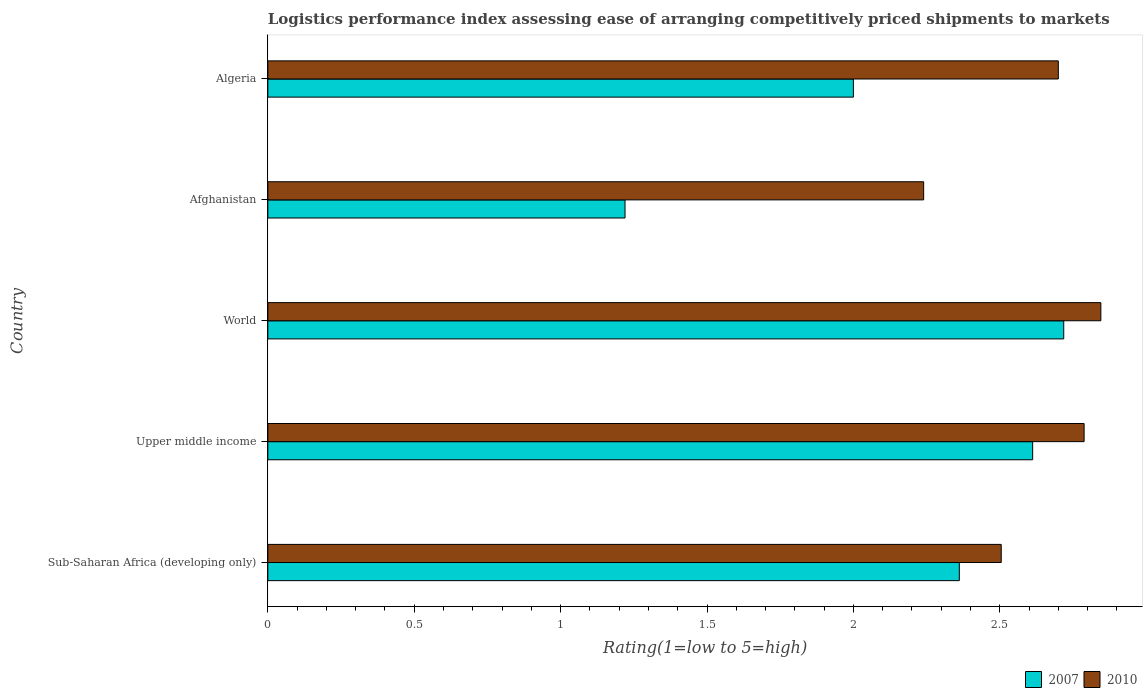How many different coloured bars are there?
Offer a very short reply. 2. Are the number of bars per tick equal to the number of legend labels?
Your response must be concise. Yes. How many bars are there on the 2nd tick from the top?
Your response must be concise. 2. How many bars are there on the 4th tick from the bottom?
Your answer should be compact. 2. What is the label of the 5th group of bars from the top?
Your response must be concise. Sub-Saharan Africa (developing only). Across all countries, what is the maximum Logistic performance index in 2007?
Your answer should be compact. 2.72. Across all countries, what is the minimum Logistic performance index in 2007?
Your answer should be very brief. 1.22. In which country was the Logistic performance index in 2007 maximum?
Your response must be concise. World. In which country was the Logistic performance index in 2007 minimum?
Make the answer very short. Afghanistan. What is the total Logistic performance index in 2010 in the graph?
Your response must be concise. 13.08. What is the difference between the Logistic performance index in 2007 in Sub-Saharan Africa (developing only) and that in Upper middle income?
Your answer should be compact. -0.25. What is the difference between the Logistic performance index in 2010 in Algeria and the Logistic performance index in 2007 in Afghanistan?
Make the answer very short. 1.48. What is the average Logistic performance index in 2010 per country?
Make the answer very short. 2.62. What is the difference between the Logistic performance index in 2010 and Logistic performance index in 2007 in World?
Your response must be concise. 0.13. In how many countries, is the Logistic performance index in 2007 greater than 0.4 ?
Give a very brief answer. 5. What is the ratio of the Logistic performance index in 2007 in Sub-Saharan Africa (developing only) to that in World?
Provide a succinct answer. 0.87. Is the Logistic performance index in 2010 in Upper middle income less than that in World?
Give a very brief answer. Yes. What is the difference between the highest and the second highest Logistic performance index in 2010?
Make the answer very short. 0.06. What is the difference between the highest and the lowest Logistic performance index in 2007?
Give a very brief answer. 1.5. In how many countries, is the Logistic performance index in 2007 greater than the average Logistic performance index in 2007 taken over all countries?
Offer a very short reply. 3. What does the 2nd bar from the bottom in World represents?
Keep it short and to the point. 2010. Are all the bars in the graph horizontal?
Give a very brief answer. Yes. Are the values on the major ticks of X-axis written in scientific E-notation?
Offer a very short reply. No. Does the graph contain any zero values?
Make the answer very short. No. Where does the legend appear in the graph?
Provide a short and direct response. Bottom right. What is the title of the graph?
Keep it short and to the point. Logistics performance index assessing ease of arranging competitively priced shipments to markets. What is the label or title of the X-axis?
Keep it short and to the point. Rating(1=low to 5=high). What is the Rating(1=low to 5=high) in 2007 in Sub-Saharan Africa (developing only)?
Give a very brief answer. 2.36. What is the Rating(1=low to 5=high) in 2010 in Sub-Saharan Africa (developing only)?
Your answer should be very brief. 2.5. What is the Rating(1=low to 5=high) of 2007 in Upper middle income?
Provide a succinct answer. 2.61. What is the Rating(1=low to 5=high) of 2010 in Upper middle income?
Provide a succinct answer. 2.79. What is the Rating(1=low to 5=high) of 2007 in World?
Offer a very short reply. 2.72. What is the Rating(1=low to 5=high) of 2010 in World?
Give a very brief answer. 2.85. What is the Rating(1=low to 5=high) in 2007 in Afghanistan?
Ensure brevity in your answer.  1.22. What is the Rating(1=low to 5=high) of 2010 in Afghanistan?
Your response must be concise. 2.24. What is the Rating(1=low to 5=high) of 2007 in Algeria?
Provide a short and direct response. 2. What is the Rating(1=low to 5=high) in 2010 in Algeria?
Offer a terse response. 2.7. Across all countries, what is the maximum Rating(1=low to 5=high) of 2007?
Your response must be concise. 2.72. Across all countries, what is the maximum Rating(1=low to 5=high) of 2010?
Keep it short and to the point. 2.85. Across all countries, what is the minimum Rating(1=low to 5=high) of 2007?
Offer a very short reply. 1.22. Across all countries, what is the minimum Rating(1=low to 5=high) in 2010?
Your answer should be very brief. 2.24. What is the total Rating(1=low to 5=high) of 2007 in the graph?
Your answer should be compact. 10.91. What is the total Rating(1=low to 5=high) of 2010 in the graph?
Offer a very short reply. 13.08. What is the difference between the Rating(1=low to 5=high) of 2007 in Sub-Saharan Africa (developing only) and that in Upper middle income?
Offer a very short reply. -0.25. What is the difference between the Rating(1=low to 5=high) of 2010 in Sub-Saharan Africa (developing only) and that in Upper middle income?
Provide a short and direct response. -0.28. What is the difference between the Rating(1=low to 5=high) of 2007 in Sub-Saharan Africa (developing only) and that in World?
Your answer should be very brief. -0.36. What is the difference between the Rating(1=low to 5=high) of 2010 in Sub-Saharan Africa (developing only) and that in World?
Ensure brevity in your answer.  -0.34. What is the difference between the Rating(1=low to 5=high) of 2007 in Sub-Saharan Africa (developing only) and that in Afghanistan?
Provide a short and direct response. 1.14. What is the difference between the Rating(1=low to 5=high) of 2010 in Sub-Saharan Africa (developing only) and that in Afghanistan?
Your answer should be compact. 0.27. What is the difference between the Rating(1=low to 5=high) in 2007 in Sub-Saharan Africa (developing only) and that in Algeria?
Make the answer very short. 0.36. What is the difference between the Rating(1=low to 5=high) of 2010 in Sub-Saharan Africa (developing only) and that in Algeria?
Keep it short and to the point. -0.2. What is the difference between the Rating(1=low to 5=high) of 2007 in Upper middle income and that in World?
Your answer should be compact. -0.11. What is the difference between the Rating(1=low to 5=high) in 2010 in Upper middle income and that in World?
Keep it short and to the point. -0.06. What is the difference between the Rating(1=low to 5=high) in 2007 in Upper middle income and that in Afghanistan?
Provide a succinct answer. 1.39. What is the difference between the Rating(1=low to 5=high) of 2010 in Upper middle income and that in Afghanistan?
Offer a terse response. 0.55. What is the difference between the Rating(1=low to 5=high) of 2007 in Upper middle income and that in Algeria?
Make the answer very short. 0.61. What is the difference between the Rating(1=low to 5=high) in 2010 in Upper middle income and that in Algeria?
Your response must be concise. 0.09. What is the difference between the Rating(1=low to 5=high) of 2007 in World and that in Afghanistan?
Ensure brevity in your answer.  1.5. What is the difference between the Rating(1=low to 5=high) of 2010 in World and that in Afghanistan?
Your response must be concise. 0.61. What is the difference between the Rating(1=low to 5=high) of 2007 in World and that in Algeria?
Give a very brief answer. 0.72. What is the difference between the Rating(1=low to 5=high) in 2010 in World and that in Algeria?
Ensure brevity in your answer.  0.15. What is the difference between the Rating(1=low to 5=high) in 2007 in Afghanistan and that in Algeria?
Make the answer very short. -0.78. What is the difference between the Rating(1=low to 5=high) in 2010 in Afghanistan and that in Algeria?
Provide a short and direct response. -0.46. What is the difference between the Rating(1=low to 5=high) of 2007 in Sub-Saharan Africa (developing only) and the Rating(1=low to 5=high) of 2010 in Upper middle income?
Keep it short and to the point. -0.43. What is the difference between the Rating(1=low to 5=high) in 2007 in Sub-Saharan Africa (developing only) and the Rating(1=low to 5=high) in 2010 in World?
Keep it short and to the point. -0.48. What is the difference between the Rating(1=low to 5=high) of 2007 in Sub-Saharan Africa (developing only) and the Rating(1=low to 5=high) of 2010 in Afghanistan?
Provide a short and direct response. 0.12. What is the difference between the Rating(1=low to 5=high) in 2007 in Sub-Saharan Africa (developing only) and the Rating(1=low to 5=high) in 2010 in Algeria?
Provide a succinct answer. -0.34. What is the difference between the Rating(1=low to 5=high) of 2007 in Upper middle income and the Rating(1=low to 5=high) of 2010 in World?
Provide a succinct answer. -0.23. What is the difference between the Rating(1=low to 5=high) of 2007 in Upper middle income and the Rating(1=low to 5=high) of 2010 in Afghanistan?
Provide a short and direct response. 0.37. What is the difference between the Rating(1=low to 5=high) in 2007 in Upper middle income and the Rating(1=low to 5=high) in 2010 in Algeria?
Keep it short and to the point. -0.09. What is the difference between the Rating(1=low to 5=high) in 2007 in World and the Rating(1=low to 5=high) in 2010 in Afghanistan?
Your response must be concise. 0.48. What is the difference between the Rating(1=low to 5=high) in 2007 in World and the Rating(1=low to 5=high) in 2010 in Algeria?
Your answer should be compact. 0.02. What is the difference between the Rating(1=low to 5=high) of 2007 in Afghanistan and the Rating(1=low to 5=high) of 2010 in Algeria?
Provide a short and direct response. -1.48. What is the average Rating(1=low to 5=high) in 2007 per country?
Ensure brevity in your answer.  2.18. What is the average Rating(1=low to 5=high) in 2010 per country?
Your response must be concise. 2.62. What is the difference between the Rating(1=low to 5=high) in 2007 and Rating(1=low to 5=high) in 2010 in Sub-Saharan Africa (developing only)?
Your response must be concise. -0.14. What is the difference between the Rating(1=low to 5=high) of 2007 and Rating(1=low to 5=high) of 2010 in Upper middle income?
Provide a succinct answer. -0.18. What is the difference between the Rating(1=low to 5=high) in 2007 and Rating(1=low to 5=high) in 2010 in World?
Provide a short and direct response. -0.13. What is the difference between the Rating(1=low to 5=high) in 2007 and Rating(1=low to 5=high) in 2010 in Afghanistan?
Offer a very short reply. -1.02. What is the ratio of the Rating(1=low to 5=high) in 2007 in Sub-Saharan Africa (developing only) to that in Upper middle income?
Your answer should be compact. 0.9. What is the ratio of the Rating(1=low to 5=high) in 2010 in Sub-Saharan Africa (developing only) to that in Upper middle income?
Make the answer very short. 0.9. What is the ratio of the Rating(1=low to 5=high) in 2007 in Sub-Saharan Africa (developing only) to that in World?
Ensure brevity in your answer.  0.87. What is the ratio of the Rating(1=low to 5=high) of 2010 in Sub-Saharan Africa (developing only) to that in World?
Give a very brief answer. 0.88. What is the ratio of the Rating(1=low to 5=high) in 2007 in Sub-Saharan Africa (developing only) to that in Afghanistan?
Offer a terse response. 1.94. What is the ratio of the Rating(1=low to 5=high) in 2010 in Sub-Saharan Africa (developing only) to that in Afghanistan?
Your answer should be compact. 1.12. What is the ratio of the Rating(1=low to 5=high) of 2007 in Sub-Saharan Africa (developing only) to that in Algeria?
Provide a succinct answer. 1.18. What is the ratio of the Rating(1=low to 5=high) in 2010 in Sub-Saharan Africa (developing only) to that in Algeria?
Your answer should be compact. 0.93. What is the ratio of the Rating(1=low to 5=high) of 2010 in Upper middle income to that in World?
Make the answer very short. 0.98. What is the ratio of the Rating(1=low to 5=high) of 2007 in Upper middle income to that in Afghanistan?
Your answer should be very brief. 2.14. What is the ratio of the Rating(1=low to 5=high) in 2010 in Upper middle income to that in Afghanistan?
Ensure brevity in your answer.  1.24. What is the ratio of the Rating(1=low to 5=high) of 2007 in Upper middle income to that in Algeria?
Ensure brevity in your answer.  1.31. What is the ratio of the Rating(1=low to 5=high) in 2010 in Upper middle income to that in Algeria?
Ensure brevity in your answer.  1.03. What is the ratio of the Rating(1=low to 5=high) of 2007 in World to that in Afghanistan?
Give a very brief answer. 2.23. What is the ratio of the Rating(1=low to 5=high) in 2010 in World to that in Afghanistan?
Offer a terse response. 1.27. What is the ratio of the Rating(1=low to 5=high) in 2007 in World to that in Algeria?
Your response must be concise. 1.36. What is the ratio of the Rating(1=low to 5=high) of 2010 in World to that in Algeria?
Provide a short and direct response. 1.05. What is the ratio of the Rating(1=low to 5=high) in 2007 in Afghanistan to that in Algeria?
Give a very brief answer. 0.61. What is the ratio of the Rating(1=low to 5=high) in 2010 in Afghanistan to that in Algeria?
Provide a succinct answer. 0.83. What is the difference between the highest and the second highest Rating(1=low to 5=high) in 2007?
Ensure brevity in your answer.  0.11. What is the difference between the highest and the second highest Rating(1=low to 5=high) of 2010?
Ensure brevity in your answer.  0.06. What is the difference between the highest and the lowest Rating(1=low to 5=high) of 2007?
Provide a short and direct response. 1.5. What is the difference between the highest and the lowest Rating(1=low to 5=high) of 2010?
Your answer should be compact. 0.61. 